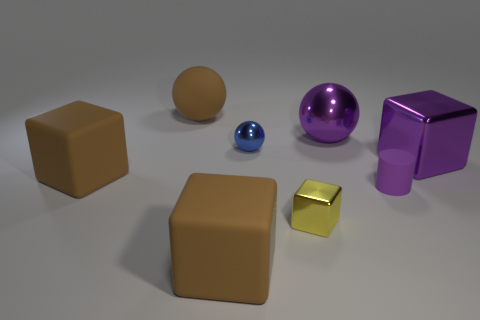Subtract all big metallic cubes. How many cubes are left? 3 Subtract all blue spheres. How many spheres are left? 2 Add 1 big rubber blocks. How many objects exist? 9 Subtract all spheres. How many objects are left? 5 Add 7 yellow things. How many yellow things are left? 8 Add 3 brown cubes. How many brown cubes exist? 5 Subtract 1 purple blocks. How many objects are left? 7 Subtract 2 cubes. How many cubes are left? 2 Subtract all gray spheres. Subtract all red blocks. How many spheres are left? 3 Subtract all yellow blocks. How many blue spheres are left? 1 